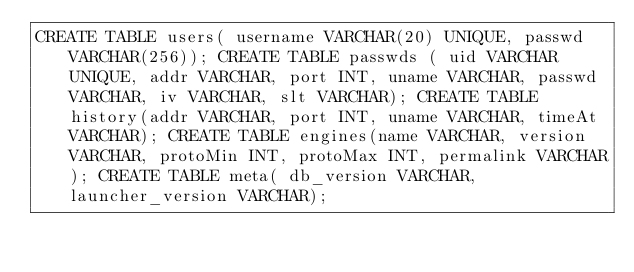<code> <loc_0><loc_0><loc_500><loc_500><_SQL_>CREATE TABLE users( username VARCHAR(20) UNIQUE, passwd VARCHAR(256)); CREATE TABLE passwds ( uid VARCHAR UNIQUE, addr VARCHAR, port INT, uname VARCHAR, passwd VARCHAR, iv VARCHAR, slt VARCHAR); CREATE TABLE history(addr VARCHAR, port INT, uname VARCHAR, timeAt VARCHAR); CREATE TABLE engines(name VARCHAR, version VARCHAR, protoMin INT, protoMax INT, permalink VARCHAR); CREATE TABLE meta( db_version VARCHAR, launcher_version VARCHAR);</code> 